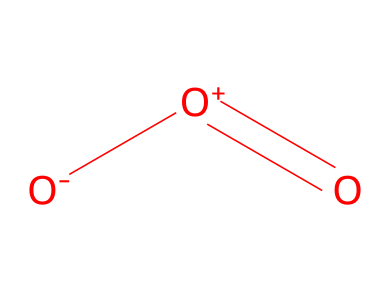What is the molecular formula of this gas? The SMILES notation represents three oxygen atoms connected in a specific arrangement. The count of oxygen atoms illustrates the molecular formula as O3.
Answer: O3 How many bonds are present in the ozone molecule? The structure indicates one double bond and one single bond between the oxygen atoms. Counting them gives a total of two bonds in the molecule.
Answer: 2 What is the charge on the first oxygen atom in this structure? The notation indicates that the first oxygen has a negative charge attached to it ([O-]), which highlights its overall electric charge in the molecule.
Answer: negative What is the hybridization of the central oxygen atom in ozone? The central oxygen atom forms a double bond with one oxygen atom and a single bond with another, thus requiring sp2 hybridization, which accommodates the geometry of this arrangement.
Answer: sp2 In which atmospheric layer is ozone primarily found? Ozone is most commonly located in the stratosphere, where its concentration is highest, hence protecting the Earth from harmful ultraviolet radiation.
Answer: stratosphere What role does ozone play in the atmosphere? Ozone acts as a protective layer absorbing UV radiation, hence playing a crucial role in shielding the Earth's surface from the sun's harmful rays.
Answer: absorbs UV radiation What type of gas is ozone categorized as? Ozone is specifically classified as a greenhouse gas due to its effect on heat retention in the atmosphere, despite being a triatomic form of oxygen.
Answer: greenhouse gas 